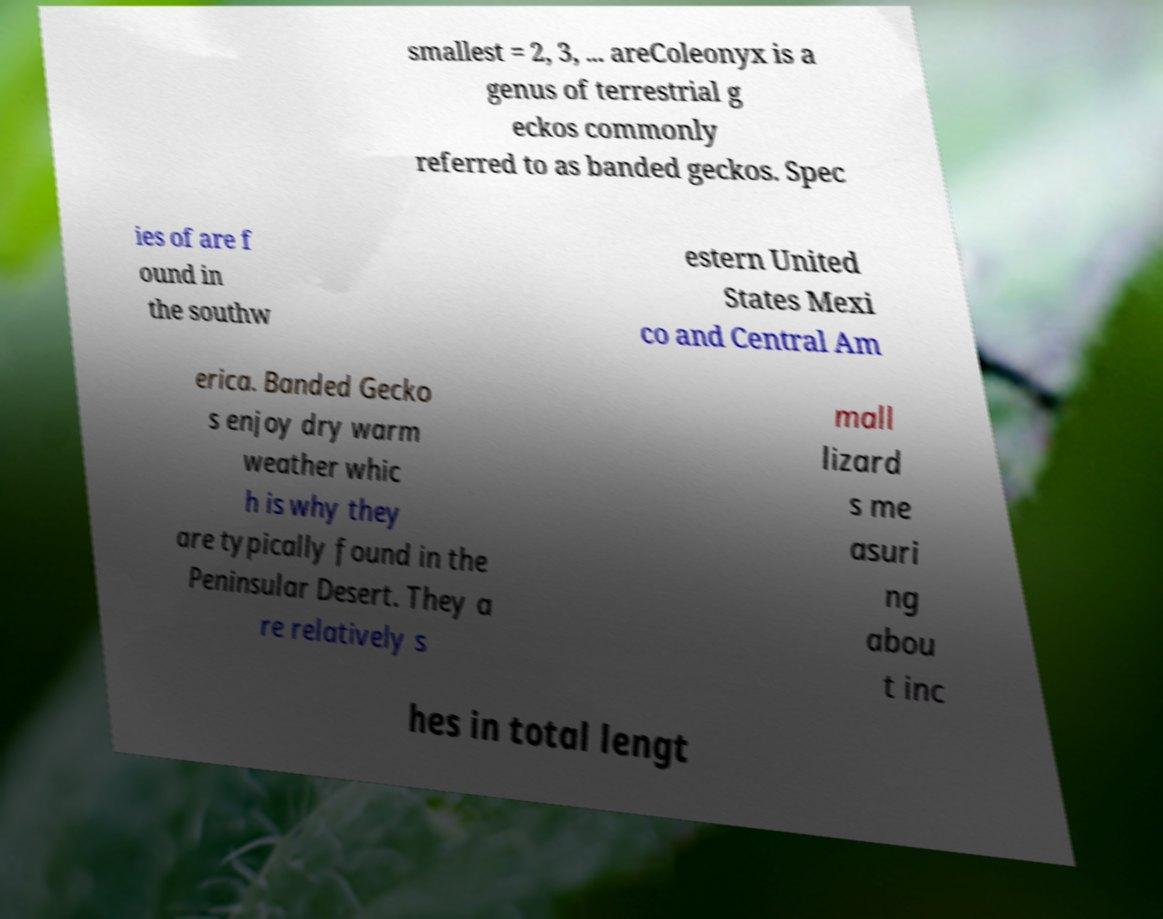Could you assist in decoding the text presented in this image and type it out clearly? smallest = 2, 3, ... areColeonyx is a genus of terrestrial g eckos commonly referred to as banded geckos. Spec ies of are f ound in the southw estern United States Mexi co and Central Am erica. Banded Gecko s enjoy dry warm weather whic h is why they are typically found in the Peninsular Desert. They a re relatively s mall lizard s me asuri ng abou t inc hes in total lengt 